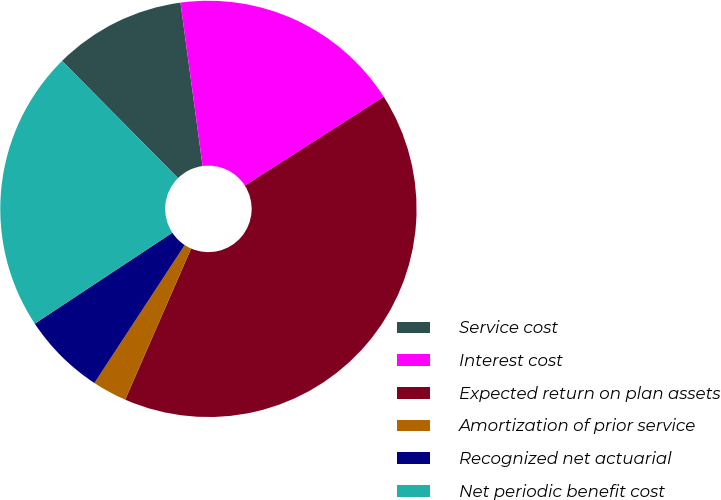Convert chart. <chart><loc_0><loc_0><loc_500><loc_500><pie_chart><fcel>Service cost<fcel>Interest cost<fcel>Expected return on plan assets<fcel>Amortization of prior service<fcel>Recognized net actuarial<fcel>Net periodic benefit cost<nl><fcel>10.27%<fcel>18.09%<fcel>40.6%<fcel>2.68%<fcel>6.48%<fcel>21.88%<nl></chart> 